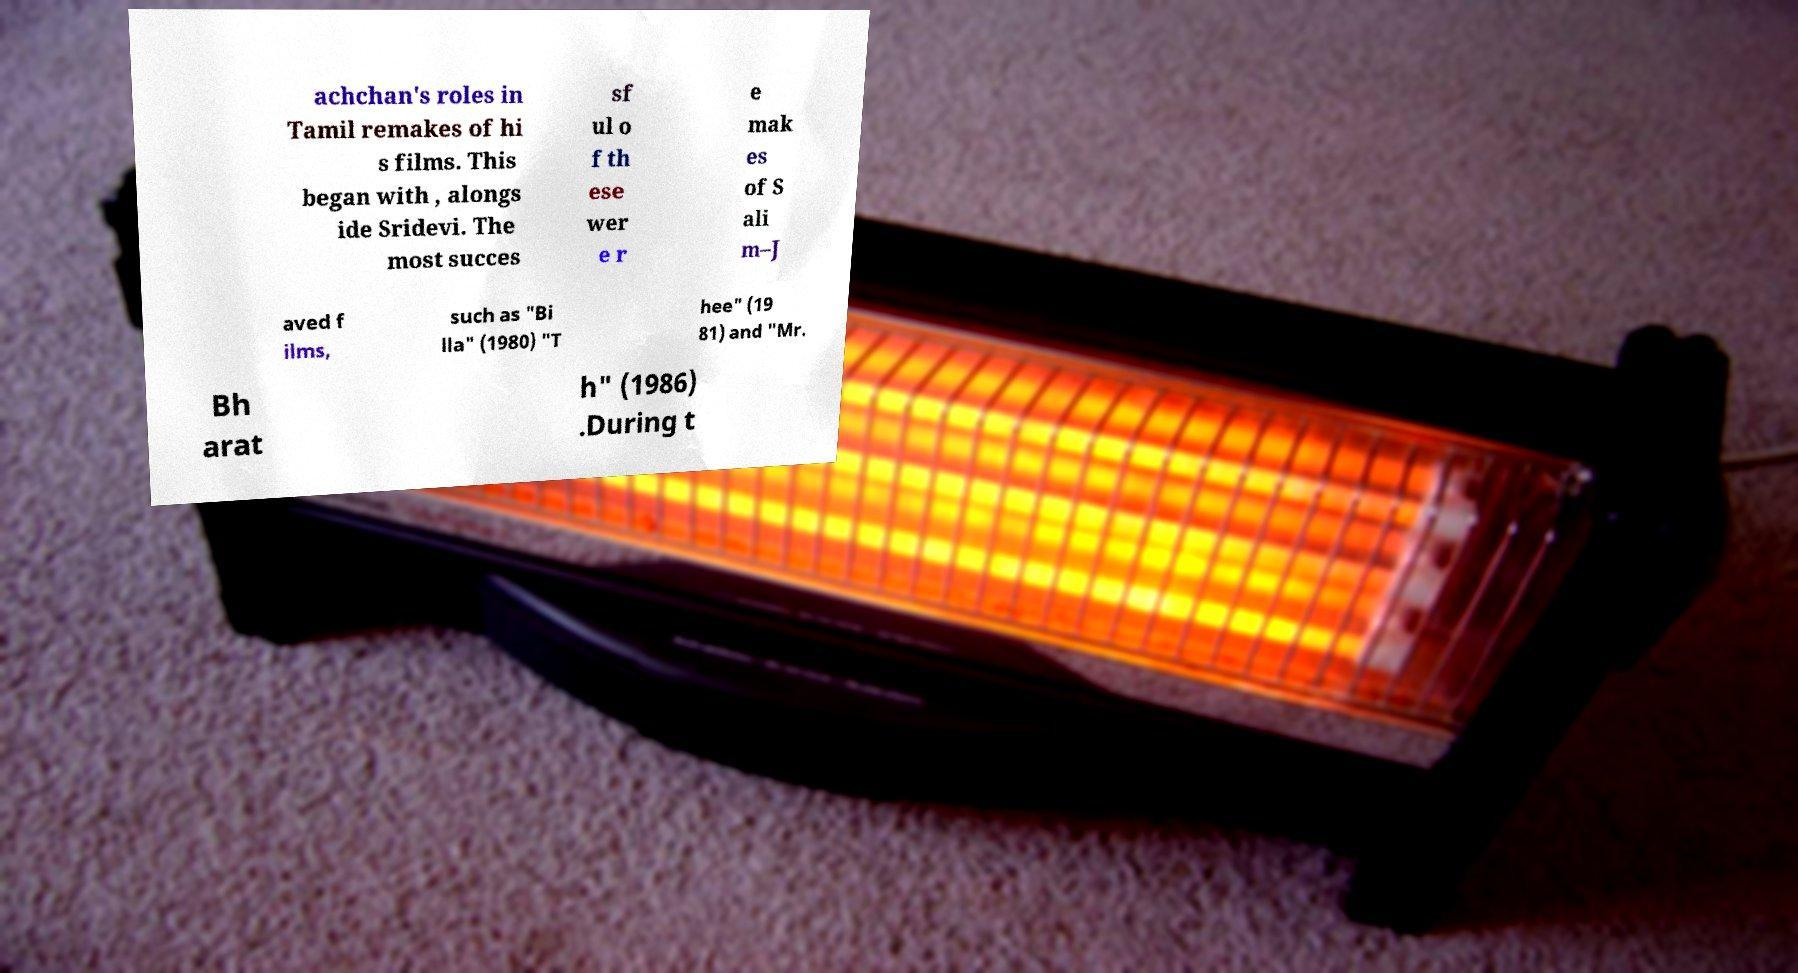What messages or text are displayed in this image? I need them in a readable, typed format. achchan's roles in Tamil remakes of hi s films. This began with , alongs ide Sridevi. The most succes sf ul o f th ese wer e r e mak es of S ali m–J aved f ilms, such as "Bi lla" (1980) "T hee" (19 81) and "Mr. Bh arat h" (1986) .During t 